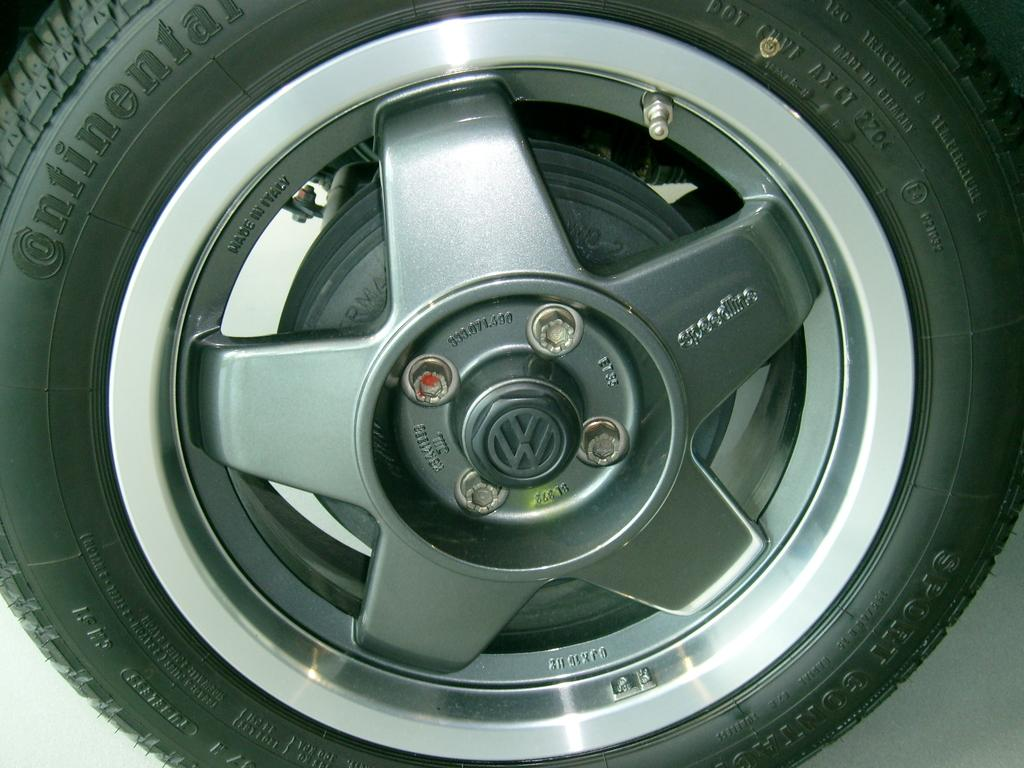What is the main object in the image? There is a tire with a wheel rim in the image. What are some features of the tire? The tire has screws and a brake. Are there any other objects related to the tire in the image? Yes, there are other objects associated with the tire. What can be seen on the tire itself? There is text on the tire. What is the color of the background in the image? The background of the image is white. How does the tire express its fear of sugar in the image? There is no indication in the image that the tire has any emotions or fears, including fear of sugar. 